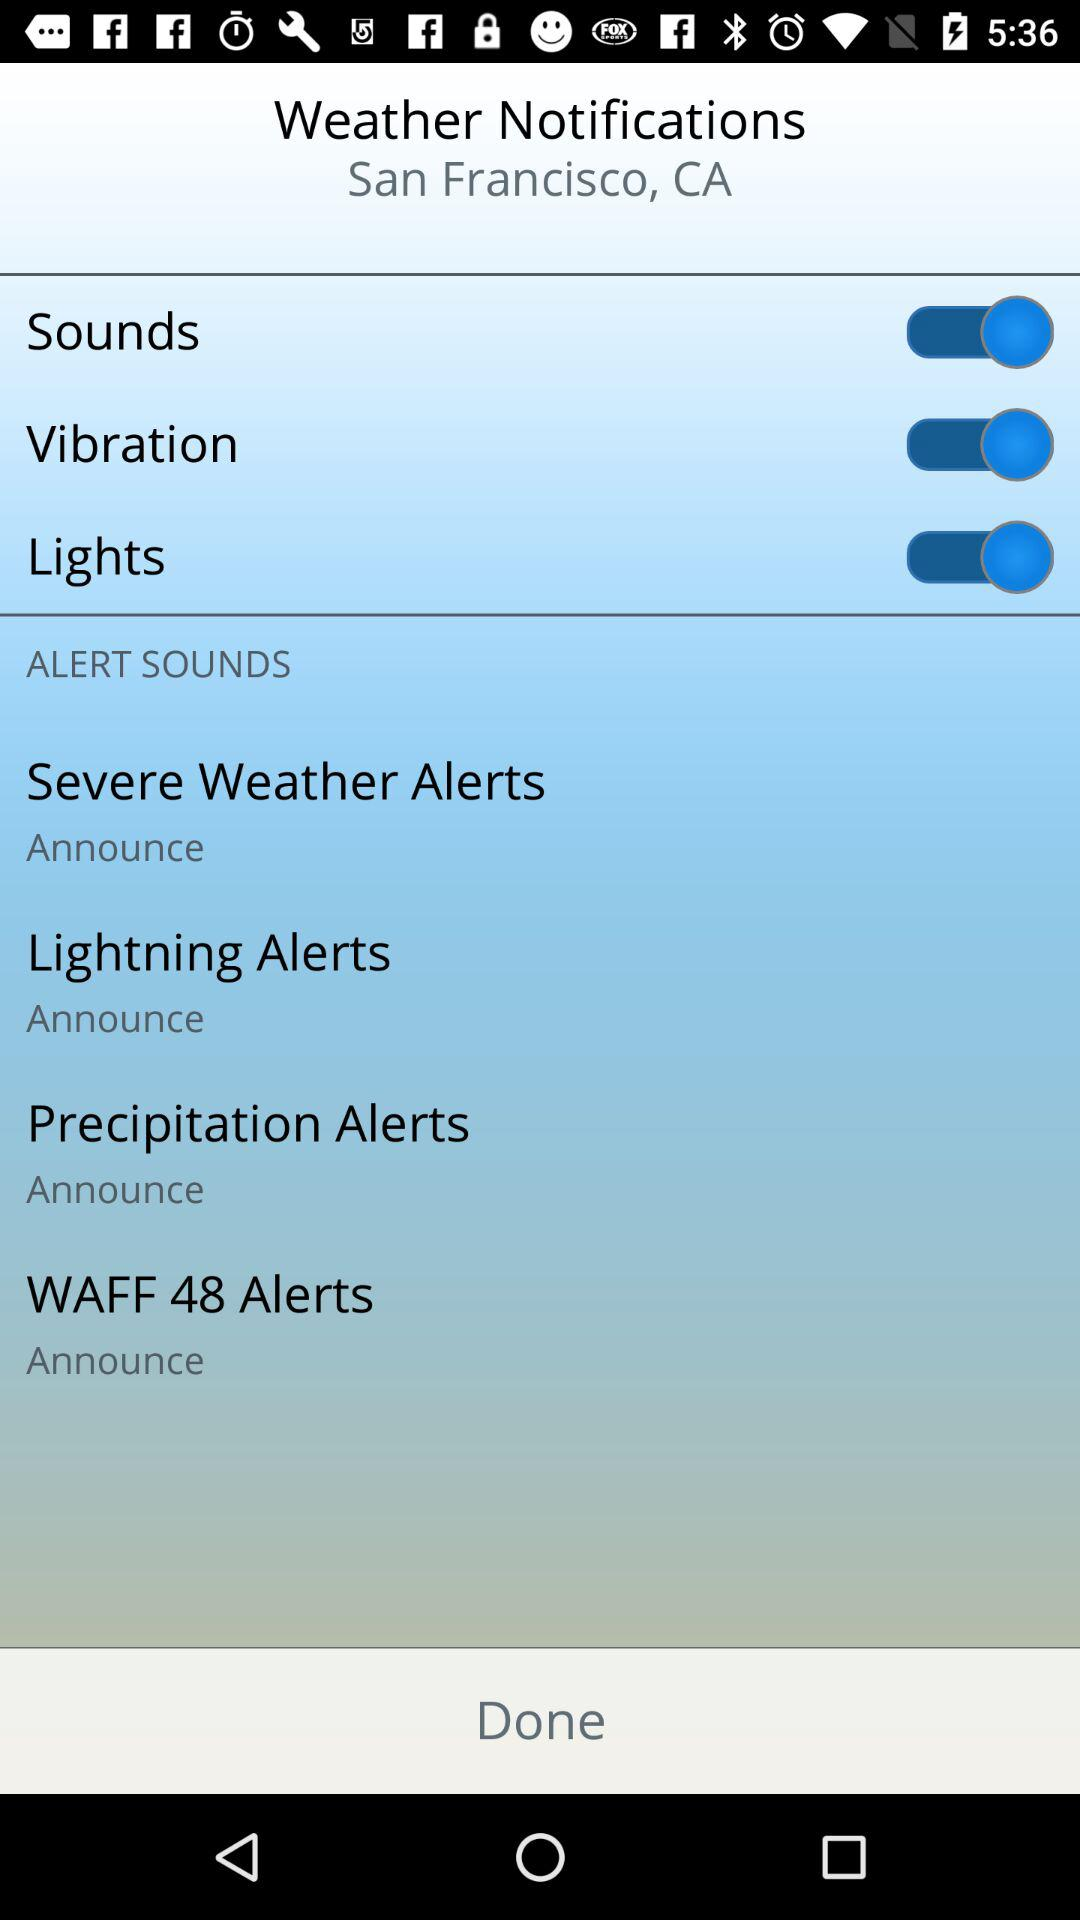What is the setting for lightning alerts? The setting for lightning alerts is "Announce". 